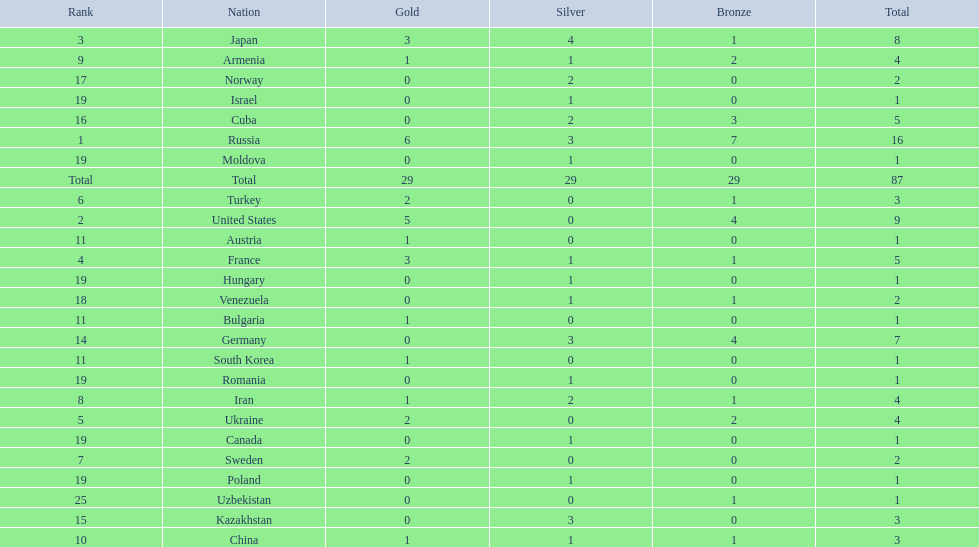How many combined gold medals did japan and france win? 6. 